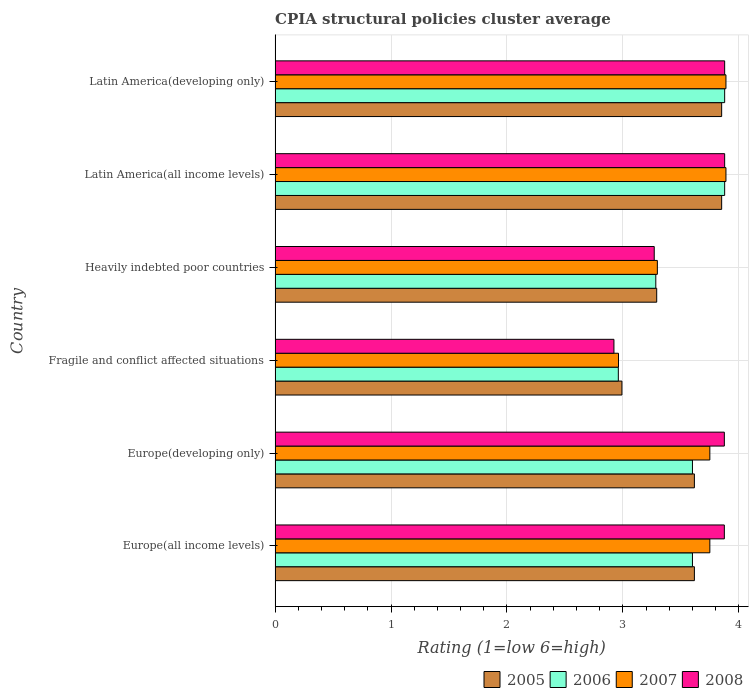How many groups of bars are there?
Ensure brevity in your answer.  6. Are the number of bars per tick equal to the number of legend labels?
Give a very brief answer. Yes. Are the number of bars on each tick of the Y-axis equal?
Ensure brevity in your answer.  Yes. How many bars are there on the 2nd tick from the top?
Your answer should be very brief. 4. How many bars are there on the 2nd tick from the bottom?
Keep it short and to the point. 4. What is the label of the 6th group of bars from the top?
Provide a short and direct response. Europe(all income levels). What is the CPIA rating in 2007 in Fragile and conflict affected situations?
Give a very brief answer. 2.96. Across all countries, what is the maximum CPIA rating in 2008?
Offer a very short reply. 3.88. Across all countries, what is the minimum CPIA rating in 2008?
Your answer should be very brief. 2.92. In which country was the CPIA rating in 2007 maximum?
Provide a succinct answer. Latin America(all income levels). In which country was the CPIA rating in 2007 minimum?
Offer a terse response. Fragile and conflict affected situations. What is the total CPIA rating in 2006 in the graph?
Offer a terse response. 21.2. What is the difference between the CPIA rating in 2005 in Europe(developing only) and that in Fragile and conflict affected situations?
Offer a terse response. 0.62. What is the difference between the CPIA rating in 2006 in Heavily indebted poor countries and the CPIA rating in 2005 in Latin America(developing only)?
Make the answer very short. -0.57. What is the average CPIA rating in 2007 per country?
Your answer should be very brief. 3.59. What is the difference between the CPIA rating in 2005 and CPIA rating in 2006 in Europe(all income levels)?
Offer a very short reply. 0.02. What is the ratio of the CPIA rating in 2007 in Europe(all income levels) to that in Heavily indebted poor countries?
Your answer should be very brief. 1.14. Is the CPIA rating in 2008 in Europe(developing only) less than that in Latin America(developing only)?
Ensure brevity in your answer.  Yes. What is the difference between the highest and the lowest CPIA rating in 2005?
Ensure brevity in your answer.  0.86. In how many countries, is the CPIA rating in 2008 greater than the average CPIA rating in 2008 taken over all countries?
Make the answer very short. 4. Is the sum of the CPIA rating in 2005 in Europe(developing only) and Fragile and conflict affected situations greater than the maximum CPIA rating in 2007 across all countries?
Your answer should be compact. Yes. What does the 1st bar from the top in Latin America(all income levels) represents?
Ensure brevity in your answer.  2008. Is it the case that in every country, the sum of the CPIA rating in 2007 and CPIA rating in 2008 is greater than the CPIA rating in 2005?
Your answer should be compact. Yes. How many bars are there?
Ensure brevity in your answer.  24. Are the values on the major ticks of X-axis written in scientific E-notation?
Give a very brief answer. No. Does the graph contain grids?
Give a very brief answer. Yes. What is the title of the graph?
Make the answer very short. CPIA structural policies cluster average. Does "1962" appear as one of the legend labels in the graph?
Your answer should be compact. No. What is the label or title of the X-axis?
Make the answer very short. Rating (1=low 6=high). What is the Rating (1=low 6=high) in 2005 in Europe(all income levels)?
Give a very brief answer. 3.62. What is the Rating (1=low 6=high) of 2007 in Europe(all income levels)?
Ensure brevity in your answer.  3.75. What is the Rating (1=low 6=high) in 2008 in Europe(all income levels)?
Your response must be concise. 3.88. What is the Rating (1=low 6=high) in 2005 in Europe(developing only)?
Offer a terse response. 3.62. What is the Rating (1=low 6=high) of 2007 in Europe(developing only)?
Provide a succinct answer. 3.75. What is the Rating (1=low 6=high) in 2008 in Europe(developing only)?
Your answer should be very brief. 3.88. What is the Rating (1=low 6=high) of 2005 in Fragile and conflict affected situations?
Keep it short and to the point. 2.99. What is the Rating (1=low 6=high) in 2006 in Fragile and conflict affected situations?
Make the answer very short. 2.96. What is the Rating (1=low 6=high) in 2007 in Fragile and conflict affected situations?
Offer a very short reply. 2.96. What is the Rating (1=low 6=high) in 2008 in Fragile and conflict affected situations?
Your response must be concise. 2.92. What is the Rating (1=low 6=high) of 2005 in Heavily indebted poor countries?
Make the answer very short. 3.29. What is the Rating (1=low 6=high) in 2006 in Heavily indebted poor countries?
Your answer should be compact. 3.28. What is the Rating (1=low 6=high) in 2007 in Heavily indebted poor countries?
Offer a terse response. 3.3. What is the Rating (1=low 6=high) in 2008 in Heavily indebted poor countries?
Offer a terse response. 3.27. What is the Rating (1=low 6=high) of 2005 in Latin America(all income levels)?
Offer a very short reply. 3.85. What is the Rating (1=low 6=high) in 2006 in Latin America(all income levels)?
Give a very brief answer. 3.88. What is the Rating (1=low 6=high) of 2007 in Latin America(all income levels)?
Provide a succinct answer. 3.89. What is the Rating (1=low 6=high) in 2008 in Latin America(all income levels)?
Your response must be concise. 3.88. What is the Rating (1=low 6=high) of 2005 in Latin America(developing only)?
Make the answer very short. 3.85. What is the Rating (1=low 6=high) of 2006 in Latin America(developing only)?
Your answer should be compact. 3.88. What is the Rating (1=low 6=high) in 2007 in Latin America(developing only)?
Your response must be concise. 3.89. What is the Rating (1=low 6=high) in 2008 in Latin America(developing only)?
Provide a succinct answer. 3.88. Across all countries, what is the maximum Rating (1=low 6=high) of 2005?
Provide a succinct answer. 3.85. Across all countries, what is the maximum Rating (1=low 6=high) of 2006?
Give a very brief answer. 3.88. Across all countries, what is the maximum Rating (1=low 6=high) in 2007?
Make the answer very short. 3.89. Across all countries, what is the maximum Rating (1=low 6=high) in 2008?
Provide a succinct answer. 3.88. Across all countries, what is the minimum Rating (1=low 6=high) of 2005?
Ensure brevity in your answer.  2.99. Across all countries, what is the minimum Rating (1=low 6=high) in 2006?
Provide a succinct answer. 2.96. Across all countries, what is the minimum Rating (1=low 6=high) of 2007?
Provide a short and direct response. 2.96. Across all countries, what is the minimum Rating (1=low 6=high) in 2008?
Your response must be concise. 2.92. What is the total Rating (1=low 6=high) of 2005 in the graph?
Offer a very short reply. 21.22. What is the total Rating (1=low 6=high) in 2006 in the graph?
Make the answer very short. 21.2. What is the total Rating (1=low 6=high) of 2007 in the graph?
Give a very brief answer. 21.54. What is the total Rating (1=low 6=high) of 2008 in the graph?
Your response must be concise. 21.7. What is the difference between the Rating (1=low 6=high) in 2007 in Europe(all income levels) and that in Europe(developing only)?
Your answer should be very brief. 0. What is the difference between the Rating (1=low 6=high) in 2008 in Europe(all income levels) and that in Europe(developing only)?
Your answer should be compact. 0. What is the difference between the Rating (1=low 6=high) in 2006 in Europe(all income levels) and that in Fragile and conflict affected situations?
Your response must be concise. 0.64. What is the difference between the Rating (1=low 6=high) of 2007 in Europe(all income levels) and that in Fragile and conflict affected situations?
Provide a short and direct response. 0.79. What is the difference between the Rating (1=low 6=high) of 2008 in Europe(all income levels) and that in Fragile and conflict affected situations?
Your answer should be compact. 0.95. What is the difference between the Rating (1=low 6=high) in 2005 in Europe(all income levels) and that in Heavily indebted poor countries?
Keep it short and to the point. 0.33. What is the difference between the Rating (1=low 6=high) of 2006 in Europe(all income levels) and that in Heavily indebted poor countries?
Make the answer very short. 0.32. What is the difference between the Rating (1=low 6=high) of 2007 in Europe(all income levels) and that in Heavily indebted poor countries?
Give a very brief answer. 0.45. What is the difference between the Rating (1=low 6=high) in 2008 in Europe(all income levels) and that in Heavily indebted poor countries?
Your response must be concise. 0.6. What is the difference between the Rating (1=low 6=high) of 2005 in Europe(all income levels) and that in Latin America(all income levels)?
Make the answer very short. -0.24. What is the difference between the Rating (1=low 6=high) in 2006 in Europe(all income levels) and that in Latin America(all income levels)?
Ensure brevity in your answer.  -0.28. What is the difference between the Rating (1=low 6=high) of 2007 in Europe(all income levels) and that in Latin America(all income levels)?
Ensure brevity in your answer.  -0.14. What is the difference between the Rating (1=low 6=high) of 2008 in Europe(all income levels) and that in Latin America(all income levels)?
Your response must be concise. -0. What is the difference between the Rating (1=low 6=high) of 2005 in Europe(all income levels) and that in Latin America(developing only)?
Offer a very short reply. -0.24. What is the difference between the Rating (1=low 6=high) of 2006 in Europe(all income levels) and that in Latin America(developing only)?
Keep it short and to the point. -0.28. What is the difference between the Rating (1=low 6=high) in 2007 in Europe(all income levels) and that in Latin America(developing only)?
Provide a short and direct response. -0.14. What is the difference between the Rating (1=low 6=high) in 2008 in Europe(all income levels) and that in Latin America(developing only)?
Make the answer very short. -0. What is the difference between the Rating (1=low 6=high) of 2005 in Europe(developing only) and that in Fragile and conflict affected situations?
Your answer should be compact. 0.62. What is the difference between the Rating (1=low 6=high) in 2006 in Europe(developing only) and that in Fragile and conflict affected situations?
Your answer should be compact. 0.64. What is the difference between the Rating (1=low 6=high) of 2007 in Europe(developing only) and that in Fragile and conflict affected situations?
Keep it short and to the point. 0.79. What is the difference between the Rating (1=low 6=high) in 2008 in Europe(developing only) and that in Fragile and conflict affected situations?
Keep it short and to the point. 0.95. What is the difference between the Rating (1=low 6=high) in 2005 in Europe(developing only) and that in Heavily indebted poor countries?
Your answer should be compact. 0.33. What is the difference between the Rating (1=low 6=high) in 2006 in Europe(developing only) and that in Heavily indebted poor countries?
Your response must be concise. 0.32. What is the difference between the Rating (1=low 6=high) of 2007 in Europe(developing only) and that in Heavily indebted poor countries?
Your answer should be very brief. 0.45. What is the difference between the Rating (1=low 6=high) of 2008 in Europe(developing only) and that in Heavily indebted poor countries?
Make the answer very short. 0.6. What is the difference between the Rating (1=low 6=high) of 2005 in Europe(developing only) and that in Latin America(all income levels)?
Ensure brevity in your answer.  -0.24. What is the difference between the Rating (1=low 6=high) in 2006 in Europe(developing only) and that in Latin America(all income levels)?
Your answer should be compact. -0.28. What is the difference between the Rating (1=low 6=high) of 2007 in Europe(developing only) and that in Latin America(all income levels)?
Your answer should be compact. -0.14. What is the difference between the Rating (1=low 6=high) in 2008 in Europe(developing only) and that in Latin America(all income levels)?
Your answer should be compact. -0. What is the difference between the Rating (1=low 6=high) of 2005 in Europe(developing only) and that in Latin America(developing only)?
Provide a succinct answer. -0.24. What is the difference between the Rating (1=low 6=high) in 2006 in Europe(developing only) and that in Latin America(developing only)?
Offer a terse response. -0.28. What is the difference between the Rating (1=low 6=high) in 2007 in Europe(developing only) and that in Latin America(developing only)?
Offer a terse response. -0.14. What is the difference between the Rating (1=low 6=high) in 2008 in Europe(developing only) and that in Latin America(developing only)?
Keep it short and to the point. -0. What is the difference between the Rating (1=low 6=high) in 2005 in Fragile and conflict affected situations and that in Heavily indebted poor countries?
Keep it short and to the point. -0.3. What is the difference between the Rating (1=low 6=high) in 2006 in Fragile and conflict affected situations and that in Heavily indebted poor countries?
Provide a short and direct response. -0.32. What is the difference between the Rating (1=low 6=high) of 2007 in Fragile and conflict affected situations and that in Heavily indebted poor countries?
Give a very brief answer. -0.34. What is the difference between the Rating (1=low 6=high) in 2008 in Fragile and conflict affected situations and that in Heavily indebted poor countries?
Ensure brevity in your answer.  -0.35. What is the difference between the Rating (1=low 6=high) in 2005 in Fragile and conflict affected situations and that in Latin America(all income levels)?
Your answer should be compact. -0.86. What is the difference between the Rating (1=low 6=high) of 2006 in Fragile and conflict affected situations and that in Latin America(all income levels)?
Provide a short and direct response. -0.92. What is the difference between the Rating (1=low 6=high) of 2007 in Fragile and conflict affected situations and that in Latin America(all income levels)?
Keep it short and to the point. -0.93. What is the difference between the Rating (1=low 6=high) of 2008 in Fragile and conflict affected situations and that in Latin America(all income levels)?
Provide a short and direct response. -0.96. What is the difference between the Rating (1=low 6=high) in 2005 in Fragile and conflict affected situations and that in Latin America(developing only)?
Give a very brief answer. -0.86. What is the difference between the Rating (1=low 6=high) of 2006 in Fragile and conflict affected situations and that in Latin America(developing only)?
Provide a succinct answer. -0.92. What is the difference between the Rating (1=low 6=high) of 2007 in Fragile and conflict affected situations and that in Latin America(developing only)?
Offer a very short reply. -0.93. What is the difference between the Rating (1=low 6=high) of 2008 in Fragile and conflict affected situations and that in Latin America(developing only)?
Provide a succinct answer. -0.96. What is the difference between the Rating (1=low 6=high) in 2005 in Heavily indebted poor countries and that in Latin America(all income levels)?
Ensure brevity in your answer.  -0.56. What is the difference between the Rating (1=low 6=high) in 2006 in Heavily indebted poor countries and that in Latin America(all income levels)?
Provide a succinct answer. -0.59. What is the difference between the Rating (1=low 6=high) in 2007 in Heavily indebted poor countries and that in Latin America(all income levels)?
Offer a terse response. -0.59. What is the difference between the Rating (1=low 6=high) in 2008 in Heavily indebted poor countries and that in Latin America(all income levels)?
Your answer should be very brief. -0.61. What is the difference between the Rating (1=low 6=high) of 2005 in Heavily indebted poor countries and that in Latin America(developing only)?
Your answer should be very brief. -0.56. What is the difference between the Rating (1=low 6=high) of 2006 in Heavily indebted poor countries and that in Latin America(developing only)?
Your response must be concise. -0.59. What is the difference between the Rating (1=low 6=high) in 2007 in Heavily indebted poor countries and that in Latin America(developing only)?
Make the answer very short. -0.59. What is the difference between the Rating (1=low 6=high) of 2008 in Heavily indebted poor countries and that in Latin America(developing only)?
Provide a short and direct response. -0.61. What is the difference between the Rating (1=low 6=high) in 2007 in Latin America(all income levels) and that in Latin America(developing only)?
Your response must be concise. 0. What is the difference between the Rating (1=low 6=high) in 2008 in Latin America(all income levels) and that in Latin America(developing only)?
Provide a succinct answer. 0. What is the difference between the Rating (1=low 6=high) in 2005 in Europe(all income levels) and the Rating (1=low 6=high) in 2006 in Europe(developing only)?
Your answer should be very brief. 0.02. What is the difference between the Rating (1=low 6=high) of 2005 in Europe(all income levels) and the Rating (1=low 6=high) of 2007 in Europe(developing only)?
Your response must be concise. -0.13. What is the difference between the Rating (1=low 6=high) in 2005 in Europe(all income levels) and the Rating (1=low 6=high) in 2008 in Europe(developing only)?
Keep it short and to the point. -0.26. What is the difference between the Rating (1=low 6=high) of 2006 in Europe(all income levels) and the Rating (1=low 6=high) of 2008 in Europe(developing only)?
Give a very brief answer. -0.28. What is the difference between the Rating (1=low 6=high) in 2007 in Europe(all income levels) and the Rating (1=low 6=high) in 2008 in Europe(developing only)?
Offer a terse response. -0.12. What is the difference between the Rating (1=low 6=high) in 2005 in Europe(all income levels) and the Rating (1=low 6=high) in 2006 in Fragile and conflict affected situations?
Keep it short and to the point. 0.66. What is the difference between the Rating (1=low 6=high) of 2005 in Europe(all income levels) and the Rating (1=low 6=high) of 2007 in Fragile and conflict affected situations?
Give a very brief answer. 0.65. What is the difference between the Rating (1=low 6=high) of 2005 in Europe(all income levels) and the Rating (1=low 6=high) of 2008 in Fragile and conflict affected situations?
Make the answer very short. 0.69. What is the difference between the Rating (1=low 6=high) in 2006 in Europe(all income levels) and the Rating (1=low 6=high) in 2007 in Fragile and conflict affected situations?
Give a very brief answer. 0.64. What is the difference between the Rating (1=low 6=high) in 2006 in Europe(all income levels) and the Rating (1=low 6=high) in 2008 in Fragile and conflict affected situations?
Offer a very short reply. 0.68. What is the difference between the Rating (1=low 6=high) in 2007 in Europe(all income levels) and the Rating (1=low 6=high) in 2008 in Fragile and conflict affected situations?
Make the answer very short. 0.83. What is the difference between the Rating (1=low 6=high) in 2005 in Europe(all income levels) and the Rating (1=low 6=high) in 2006 in Heavily indebted poor countries?
Your answer should be compact. 0.33. What is the difference between the Rating (1=low 6=high) of 2005 in Europe(all income levels) and the Rating (1=low 6=high) of 2007 in Heavily indebted poor countries?
Keep it short and to the point. 0.32. What is the difference between the Rating (1=low 6=high) of 2005 in Europe(all income levels) and the Rating (1=low 6=high) of 2008 in Heavily indebted poor countries?
Your response must be concise. 0.35. What is the difference between the Rating (1=low 6=high) in 2006 in Europe(all income levels) and the Rating (1=low 6=high) in 2007 in Heavily indebted poor countries?
Ensure brevity in your answer.  0.3. What is the difference between the Rating (1=low 6=high) in 2006 in Europe(all income levels) and the Rating (1=low 6=high) in 2008 in Heavily indebted poor countries?
Ensure brevity in your answer.  0.33. What is the difference between the Rating (1=low 6=high) in 2007 in Europe(all income levels) and the Rating (1=low 6=high) in 2008 in Heavily indebted poor countries?
Ensure brevity in your answer.  0.48. What is the difference between the Rating (1=low 6=high) of 2005 in Europe(all income levels) and the Rating (1=low 6=high) of 2006 in Latin America(all income levels)?
Your response must be concise. -0.26. What is the difference between the Rating (1=low 6=high) in 2005 in Europe(all income levels) and the Rating (1=low 6=high) in 2007 in Latin America(all income levels)?
Offer a terse response. -0.27. What is the difference between the Rating (1=low 6=high) in 2005 in Europe(all income levels) and the Rating (1=low 6=high) in 2008 in Latin America(all income levels)?
Offer a terse response. -0.26. What is the difference between the Rating (1=low 6=high) of 2006 in Europe(all income levels) and the Rating (1=low 6=high) of 2007 in Latin America(all income levels)?
Make the answer very short. -0.29. What is the difference between the Rating (1=low 6=high) in 2006 in Europe(all income levels) and the Rating (1=low 6=high) in 2008 in Latin America(all income levels)?
Your answer should be compact. -0.28. What is the difference between the Rating (1=low 6=high) in 2007 in Europe(all income levels) and the Rating (1=low 6=high) in 2008 in Latin America(all income levels)?
Offer a very short reply. -0.13. What is the difference between the Rating (1=low 6=high) of 2005 in Europe(all income levels) and the Rating (1=low 6=high) of 2006 in Latin America(developing only)?
Give a very brief answer. -0.26. What is the difference between the Rating (1=low 6=high) of 2005 in Europe(all income levels) and the Rating (1=low 6=high) of 2007 in Latin America(developing only)?
Offer a terse response. -0.27. What is the difference between the Rating (1=low 6=high) in 2005 in Europe(all income levels) and the Rating (1=low 6=high) in 2008 in Latin America(developing only)?
Make the answer very short. -0.26. What is the difference between the Rating (1=low 6=high) of 2006 in Europe(all income levels) and the Rating (1=low 6=high) of 2007 in Latin America(developing only)?
Your response must be concise. -0.29. What is the difference between the Rating (1=low 6=high) in 2006 in Europe(all income levels) and the Rating (1=low 6=high) in 2008 in Latin America(developing only)?
Provide a succinct answer. -0.28. What is the difference between the Rating (1=low 6=high) in 2007 in Europe(all income levels) and the Rating (1=low 6=high) in 2008 in Latin America(developing only)?
Give a very brief answer. -0.13. What is the difference between the Rating (1=low 6=high) in 2005 in Europe(developing only) and the Rating (1=low 6=high) in 2006 in Fragile and conflict affected situations?
Ensure brevity in your answer.  0.66. What is the difference between the Rating (1=low 6=high) in 2005 in Europe(developing only) and the Rating (1=low 6=high) in 2007 in Fragile and conflict affected situations?
Offer a terse response. 0.65. What is the difference between the Rating (1=low 6=high) of 2005 in Europe(developing only) and the Rating (1=low 6=high) of 2008 in Fragile and conflict affected situations?
Offer a terse response. 0.69. What is the difference between the Rating (1=low 6=high) in 2006 in Europe(developing only) and the Rating (1=low 6=high) in 2007 in Fragile and conflict affected situations?
Make the answer very short. 0.64. What is the difference between the Rating (1=low 6=high) in 2006 in Europe(developing only) and the Rating (1=low 6=high) in 2008 in Fragile and conflict affected situations?
Provide a short and direct response. 0.68. What is the difference between the Rating (1=low 6=high) in 2007 in Europe(developing only) and the Rating (1=low 6=high) in 2008 in Fragile and conflict affected situations?
Make the answer very short. 0.83. What is the difference between the Rating (1=low 6=high) of 2005 in Europe(developing only) and the Rating (1=low 6=high) of 2006 in Heavily indebted poor countries?
Provide a succinct answer. 0.33. What is the difference between the Rating (1=low 6=high) in 2005 in Europe(developing only) and the Rating (1=low 6=high) in 2007 in Heavily indebted poor countries?
Provide a short and direct response. 0.32. What is the difference between the Rating (1=low 6=high) in 2005 in Europe(developing only) and the Rating (1=low 6=high) in 2008 in Heavily indebted poor countries?
Your answer should be very brief. 0.35. What is the difference between the Rating (1=low 6=high) of 2006 in Europe(developing only) and the Rating (1=low 6=high) of 2007 in Heavily indebted poor countries?
Your answer should be very brief. 0.3. What is the difference between the Rating (1=low 6=high) of 2006 in Europe(developing only) and the Rating (1=low 6=high) of 2008 in Heavily indebted poor countries?
Keep it short and to the point. 0.33. What is the difference between the Rating (1=low 6=high) in 2007 in Europe(developing only) and the Rating (1=low 6=high) in 2008 in Heavily indebted poor countries?
Give a very brief answer. 0.48. What is the difference between the Rating (1=low 6=high) in 2005 in Europe(developing only) and the Rating (1=low 6=high) in 2006 in Latin America(all income levels)?
Provide a short and direct response. -0.26. What is the difference between the Rating (1=low 6=high) in 2005 in Europe(developing only) and the Rating (1=low 6=high) in 2007 in Latin America(all income levels)?
Provide a short and direct response. -0.27. What is the difference between the Rating (1=low 6=high) in 2005 in Europe(developing only) and the Rating (1=low 6=high) in 2008 in Latin America(all income levels)?
Ensure brevity in your answer.  -0.26. What is the difference between the Rating (1=low 6=high) in 2006 in Europe(developing only) and the Rating (1=low 6=high) in 2007 in Latin America(all income levels)?
Offer a very short reply. -0.29. What is the difference between the Rating (1=low 6=high) of 2006 in Europe(developing only) and the Rating (1=low 6=high) of 2008 in Latin America(all income levels)?
Your answer should be very brief. -0.28. What is the difference between the Rating (1=low 6=high) in 2007 in Europe(developing only) and the Rating (1=low 6=high) in 2008 in Latin America(all income levels)?
Offer a terse response. -0.13. What is the difference between the Rating (1=low 6=high) of 2005 in Europe(developing only) and the Rating (1=low 6=high) of 2006 in Latin America(developing only)?
Provide a succinct answer. -0.26. What is the difference between the Rating (1=low 6=high) of 2005 in Europe(developing only) and the Rating (1=low 6=high) of 2007 in Latin America(developing only)?
Your response must be concise. -0.27. What is the difference between the Rating (1=low 6=high) of 2005 in Europe(developing only) and the Rating (1=low 6=high) of 2008 in Latin America(developing only)?
Your answer should be very brief. -0.26. What is the difference between the Rating (1=low 6=high) in 2006 in Europe(developing only) and the Rating (1=low 6=high) in 2007 in Latin America(developing only)?
Your answer should be very brief. -0.29. What is the difference between the Rating (1=low 6=high) in 2006 in Europe(developing only) and the Rating (1=low 6=high) in 2008 in Latin America(developing only)?
Your response must be concise. -0.28. What is the difference between the Rating (1=low 6=high) in 2007 in Europe(developing only) and the Rating (1=low 6=high) in 2008 in Latin America(developing only)?
Your answer should be compact. -0.13. What is the difference between the Rating (1=low 6=high) in 2005 in Fragile and conflict affected situations and the Rating (1=low 6=high) in 2006 in Heavily indebted poor countries?
Make the answer very short. -0.29. What is the difference between the Rating (1=low 6=high) in 2005 in Fragile and conflict affected situations and the Rating (1=low 6=high) in 2007 in Heavily indebted poor countries?
Offer a terse response. -0.31. What is the difference between the Rating (1=low 6=high) in 2005 in Fragile and conflict affected situations and the Rating (1=low 6=high) in 2008 in Heavily indebted poor countries?
Offer a very short reply. -0.28. What is the difference between the Rating (1=low 6=high) of 2006 in Fragile and conflict affected situations and the Rating (1=low 6=high) of 2007 in Heavily indebted poor countries?
Your answer should be very brief. -0.34. What is the difference between the Rating (1=low 6=high) of 2006 in Fragile and conflict affected situations and the Rating (1=low 6=high) of 2008 in Heavily indebted poor countries?
Make the answer very short. -0.31. What is the difference between the Rating (1=low 6=high) in 2007 in Fragile and conflict affected situations and the Rating (1=low 6=high) in 2008 in Heavily indebted poor countries?
Offer a very short reply. -0.31. What is the difference between the Rating (1=low 6=high) of 2005 in Fragile and conflict affected situations and the Rating (1=low 6=high) of 2006 in Latin America(all income levels)?
Offer a terse response. -0.89. What is the difference between the Rating (1=low 6=high) in 2005 in Fragile and conflict affected situations and the Rating (1=low 6=high) in 2007 in Latin America(all income levels)?
Give a very brief answer. -0.9. What is the difference between the Rating (1=low 6=high) in 2005 in Fragile and conflict affected situations and the Rating (1=low 6=high) in 2008 in Latin America(all income levels)?
Offer a terse response. -0.89. What is the difference between the Rating (1=low 6=high) of 2006 in Fragile and conflict affected situations and the Rating (1=low 6=high) of 2007 in Latin America(all income levels)?
Offer a terse response. -0.93. What is the difference between the Rating (1=low 6=high) of 2006 in Fragile and conflict affected situations and the Rating (1=low 6=high) of 2008 in Latin America(all income levels)?
Your answer should be very brief. -0.92. What is the difference between the Rating (1=low 6=high) of 2007 in Fragile and conflict affected situations and the Rating (1=low 6=high) of 2008 in Latin America(all income levels)?
Your answer should be very brief. -0.92. What is the difference between the Rating (1=low 6=high) of 2005 in Fragile and conflict affected situations and the Rating (1=low 6=high) of 2006 in Latin America(developing only)?
Your answer should be compact. -0.89. What is the difference between the Rating (1=low 6=high) of 2005 in Fragile and conflict affected situations and the Rating (1=low 6=high) of 2007 in Latin America(developing only)?
Offer a terse response. -0.9. What is the difference between the Rating (1=low 6=high) in 2005 in Fragile and conflict affected situations and the Rating (1=low 6=high) in 2008 in Latin America(developing only)?
Ensure brevity in your answer.  -0.89. What is the difference between the Rating (1=low 6=high) in 2006 in Fragile and conflict affected situations and the Rating (1=low 6=high) in 2007 in Latin America(developing only)?
Provide a short and direct response. -0.93. What is the difference between the Rating (1=low 6=high) of 2006 in Fragile and conflict affected situations and the Rating (1=low 6=high) of 2008 in Latin America(developing only)?
Ensure brevity in your answer.  -0.92. What is the difference between the Rating (1=low 6=high) of 2007 in Fragile and conflict affected situations and the Rating (1=low 6=high) of 2008 in Latin America(developing only)?
Make the answer very short. -0.92. What is the difference between the Rating (1=low 6=high) in 2005 in Heavily indebted poor countries and the Rating (1=low 6=high) in 2006 in Latin America(all income levels)?
Provide a succinct answer. -0.59. What is the difference between the Rating (1=low 6=high) of 2005 in Heavily indebted poor countries and the Rating (1=low 6=high) of 2007 in Latin America(all income levels)?
Offer a terse response. -0.6. What is the difference between the Rating (1=low 6=high) in 2005 in Heavily indebted poor countries and the Rating (1=low 6=high) in 2008 in Latin America(all income levels)?
Offer a terse response. -0.59. What is the difference between the Rating (1=low 6=high) of 2006 in Heavily indebted poor countries and the Rating (1=low 6=high) of 2007 in Latin America(all income levels)?
Provide a short and direct response. -0.61. What is the difference between the Rating (1=low 6=high) in 2006 in Heavily indebted poor countries and the Rating (1=low 6=high) in 2008 in Latin America(all income levels)?
Give a very brief answer. -0.59. What is the difference between the Rating (1=low 6=high) of 2007 in Heavily indebted poor countries and the Rating (1=low 6=high) of 2008 in Latin America(all income levels)?
Make the answer very short. -0.58. What is the difference between the Rating (1=low 6=high) of 2005 in Heavily indebted poor countries and the Rating (1=low 6=high) of 2006 in Latin America(developing only)?
Offer a very short reply. -0.59. What is the difference between the Rating (1=low 6=high) of 2005 in Heavily indebted poor countries and the Rating (1=low 6=high) of 2007 in Latin America(developing only)?
Your response must be concise. -0.6. What is the difference between the Rating (1=low 6=high) of 2005 in Heavily indebted poor countries and the Rating (1=low 6=high) of 2008 in Latin America(developing only)?
Provide a short and direct response. -0.59. What is the difference between the Rating (1=low 6=high) in 2006 in Heavily indebted poor countries and the Rating (1=low 6=high) in 2007 in Latin America(developing only)?
Offer a terse response. -0.61. What is the difference between the Rating (1=low 6=high) in 2006 in Heavily indebted poor countries and the Rating (1=low 6=high) in 2008 in Latin America(developing only)?
Your answer should be compact. -0.59. What is the difference between the Rating (1=low 6=high) of 2007 in Heavily indebted poor countries and the Rating (1=low 6=high) of 2008 in Latin America(developing only)?
Give a very brief answer. -0.58. What is the difference between the Rating (1=low 6=high) of 2005 in Latin America(all income levels) and the Rating (1=low 6=high) of 2006 in Latin America(developing only)?
Your answer should be very brief. -0.03. What is the difference between the Rating (1=low 6=high) of 2005 in Latin America(all income levels) and the Rating (1=low 6=high) of 2007 in Latin America(developing only)?
Provide a succinct answer. -0.04. What is the difference between the Rating (1=low 6=high) in 2005 in Latin America(all income levels) and the Rating (1=low 6=high) in 2008 in Latin America(developing only)?
Offer a terse response. -0.03. What is the difference between the Rating (1=low 6=high) of 2006 in Latin America(all income levels) and the Rating (1=low 6=high) of 2007 in Latin America(developing only)?
Make the answer very short. -0.01. What is the difference between the Rating (1=low 6=high) of 2007 in Latin America(all income levels) and the Rating (1=low 6=high) of 2008 in Latin America(developing only)?
Provide a succinct answer. 0.01. What is the average Rating (1=low 6=high) in 2005 per country?
Your answer should be compact. 3.54. What is the average Rating (1=low 6=high) of 2006 per country?
Provide a short and direct response. 3.53. What is the average Rating (1=low 6=high) in 2007 per country?
Your response must be concise. 3.59. What is the average Rating (1=low 6=high) of 2008 per country?
Provide a short and direct response. 3.62. What is the difference between the Rating (1=low 6=high) in 2005 and Rating (1=low 6=high) in 2006 in Europe(all income levels)?
Provide a short and direct response. 0.02. What is the difference between the Rating (1=low 6=high) of 2005 and Rating (1=low 6=high) of 2007 in Europe(all income levels)?
Provide a short and direct response. -0.13. What is the difference between the Rating (1=low 6=high) in 2005 and Rating (1=low 6=high) in 2008 in Europe(all income levels)?
Give a very brief answer. -0.26. What is the difference between the Rating (1=low 6=high) in 2006 and Rating (1=low 6=high) in 2007 in Europe(all income levels)?
Give a very brief answer. -0.15. What is the difference between the Rating (1=low 6=high) in 2006 and Rating (1=low 6=high) in 2008 in Europe(all income levels)?
Give a very brief answer. -0.28. What is the difference between the Rating (1=low 6=high) in 2007 and Rating (1=low 6=high) in 2008 in Europe(all income levels)?
Your answer should be compact. -0.12. What is the difference between the Rating (1=low 6=high) in 2005 and Rating (1=low 6=high) in 2006 in Europe(developing only)?
Offer a terse response. 0.02. What is the difference between the Rating (1=low 6=high) of 2005 and Rating (1=low 6=high) of 2007 in Europe(developing only)?
Ensure brevity in your answer.  -0.13. What is the difference between the Rating (1=low 6=high) in 2005 and Rating (1=low 6=high) in 2008 in Europe(developing only)?
Keep it short and to the point. -0.26. What is the difference between the Rating (1=low 6=high) in 2006 and Rating (1=low 6=high) in 2007 in Europe(developing only)?
Provide a short and direct response. -0.15. What is the difference between the Rating (1=low 6=high) in 2006 and Rating (1=low 6=high) in 2008 in Europe(developing only)?
Give a very brief answer. -0.28. What is the difference between the Rating (1=low 6=high) of 2007 and Rating (1=low 6=high) of 2008 in Europe(developing only)?
Make the answer very short. -0.12. What is the difference between the Rating (1=low 6=high) of 2005 and Rating (1=low 6=high) of 2006 in Fragile and conflict affected situations?
Make the answer very short. 0.03. What is the difference between the Rating (1=low 6=high) of 2005 and Rating (1=low 6=high) of 2007 in Fragile and conflict affected situations?
Make the answer very short. 0.03. What is the difference between the Rating (1=low 6=high) in 2005 and Rating (1=low 6=high) in 2008 in Fragile and conflict affected situations?
Offer a terse response. 0.07. What is the difference between the Rating (1=low 6=high) in 2006 and Rating (1=low 6=high) in 2007 in Fragile and conflict affected situations?
Provide a succinct answer. -0. What is the difference between the Rating (1=low 6=high) of 2006 and Rating (1=low 6=high) of 2008 in Fragile and conflict affected situations?
Ensure brevity in your answer.  0.04. What is the difference between the Rating (1=low 6=high) in 2007 and Rating (1=low 6=high) in 2008 in Fragile and conflict affected situations?
Your response must be concise. 0.04. What is the difference between the Rating (1=low 6=high) of 2005 and Rating (1=low 6=high) of 2006 in Heavily indebted poor countries?
Offer a terse response. 0.01. What is the difference between the Rating (1=low 6=high) in 2005 and Rating (1=low 6=high) in 2007 in Heavily indebted poor countries?
Keep it short and to the point. -0.01. What is the difference between the Rating (1=low 6=high) of 2005 and Rating (1=low 6=high) of 2008 in Heavily indebted poor countries?
Give a very brief answer. 0.02. What is the difference between the Rating (1=low 6=high) in 2006 and Rating (1=low 6=high) in 2007 in Heavily indebted poor countries?
Provide a succinct answer. -0.01. What is the difference between the Rating (1=low 6=high) of 2006 and Rating (1=low 6=high) of 2008 in Heavily indebted poor countries?
Make the answer very short. 0.01. What is the difference between the Rating (1=low 6=high) in 2007 and Rating (1=low 6=high) in 2008 in Heavily indebted poor countries?
Provide a short and direct response. 0.03. What is the difference between the Rating (1=low 6=high) in 2005 and Rating (1=low 6=high) in 2006 in Latin America(all income levels)?
Your response must be concise. -0.03. What is the difference between the Rating (1=low 6=high) of 2005 and Rating (1=low 6=high) of 2007 in Latin America(all income levels)?
Keep it short and to the point. -0.04. What is the difference between the Rating (1=low 6=high) in 2005 and Rating (1=low 6=high) in 2008 in Latin America(all income levels)?
Offer a terse response. -0.03. What is the difference between the Rating (1=low 6=high) of 2006 and Rating (1=low 6=high) of 2007 in Latin America(all income levels)?
Provide a succinct answer. -0.01. What is the difference between the Rating (1=low 6=high) in 2007 and Rating (1=low 6=high) in 2008 in Latin America(all income levels)?
Provide a succinct answer. 0.01. What is the difference between the Rating (1=low 6=high) of 2005 and Rating (1=low 6=high) of 2006 in Latin America(developing only)?
Give a very brief answer. -0.03. What is the difference between the Rating (1=low 6=high) of 2005 and Rating (1=low 6=high) of 2007 in Latin America(developing only)?
Make the answer very short. -0.04. What is the difference between the Rating (1=low 6=high) of 2005 and Rating (1=low 6=high) of 2008 in Latin America(developing only)?
Your answer should be very brief. -0.03. What is the difference between the Rating (1=low 6=high) in 2006 and Rating (1=low 6=high) in 2007 in Latin America(developing only)?
Keep it short and to the point. -0.01. What is the difference between the Rating (1=low 6=high) in 2006 and Rating (1=low 6=high) in 2008 in Latin America(developing only)?
Offer a very short reply. 0. What is the difference between the Rating (1=low 6=high) in 2007 and Rating (1=low 6=high) in 2008 in Latin America(developing only)?
Provide a succinct answer. 0.01. What is the ratio of the Rating (1=low 6=high) in 2005 in Europe(all income levels) to that in Europe(developing only)?
Offer a terse response. 1. What is the ratio of the Rating (1=low 6=high) of 2007 in Europe(all income levels) to that in Europe(developing only)?
Provide a short and direct response. 1. What is the ratio of the Rating (1=low 6=high) of 2008 in Europe(all income levels) to that in Europe(developing only)?
Offer a terse response. 1. What is the ratio of the Rating (1=low 6=high) of 2005 in Europe(all income levels) to that in Fragile and conflict affected situations?
Provide a succinct answer. 1.21. What is the ratio of the Rating (1=low 6=high) of 2006 in Europe(all income levels) to that in Fragile and conflict affected situations?
Ensure brevity in your answer.  1.22. What is the ratio of the Rating (1=low 6=high) of 2007 in Europe(all income levels) to that in Fragile and conflict affected situations?
Offer a terse response. 1.27. What is the ratio of the Rating (1=low 6=high) in 2008 in Europe(all income levels) to that in Fragile and conflict affected situations?
Your answer should be compact. 1.33. What is the ratio of the Rating (1=low 6=high) of 2005 in Europe(all income levels) to that in Heavily indebted poor countries?
Make the answer very short. 1.1. What is the ratio of the Rating (1=low 6=high) in 2006 in Europe(all income levels) to that in Heavily indebted poor countries?
Give a very brief answer. 1.1. What is the ratio of the Rating (1=low 6=high) of 2007 in Europe(all income levels) to that in Heavily indebted poor countries?
Keep it short and to the point. 1.14. What is the ratio of the Rating (1=low 6=high) of 2008 in Europe(all income levels) to that in Heavily indebted poor countries?
Make the answer very short. 1.18. What is the ratio of the Rating (1=low 6=high) of 2005 in Europe(all income levels) to that in Latin America(all income levels)?
Provide a short and direct response. 0.94. What is the ratio of the Rating (1=low 6=high) in 2006 in Europe(all income levels) to that in Latin America(all income levels)?
Make the answer very short. 0.93. What is the ratio of the Rating (1=low 6=high) of 2007 in Europe(all income levels) to that in Latin America(all income levels)?
Give a very brief answer. 0.96. What is the ratio of the Rating (1=low 6=high) in 2005 in Europe(all income levels) to that in Latin America(developing only)?
Give a very brief answer. 0.94. What is the ratio of the Rating (1=low 6=high) in 2006 in Europe(all income levels) to that in Latin America(developing only)?
Provide a short and direct response. 0.93. What is the ratio of the Rating (1=low 6=high) in 2008 in Europe(all income levels) to that in Latin America(developing only)?
Make the answer very short. 1. What is the ratio of the Rating (1=low 6=high) of 2005 in Europe(developing only) to that in Fragile and conflict affected situations?
Provide a short and direct response. 1.21. What is the ratio of the Rating (1=low 6=high) in 2006 in Europe(developing only) to that in Fragile and conflict affected situations?
Your answer should be very brief. 1.22. What is the ratio of the Rating (1=low 6=high) of 2007 in Europe(developing only) to that in Fragile and conflict affected situations?
Ensure brevity in your answer.  1.27. What is the ratio of the Rating (1=low 6=high) in 2008 in Europe(developing only) to that in Fragile and conflict affected situations?
Offer a terse response. 1.33. What is the ratio of the Rating (1=low 6=high) of 2005 in Europe(developing only) to that in Heavily indebted poor countries?
Ensure brevity in your answer.  1.1. What is the ratio of the Rating (1=low 6=high) in 2006 in Europe(developing only) to that in Heavily indebted poor countries?
Keep it short and to the point. 1.1. What is the ratio of the Rating (1=low 6=high) of 2007 in Europe(developing only) to that in Heavily indebted poor countries?
Offer a very short reply. 1.14. What is the ratio of the Rating (1=low 6=high) in 2008 in Europe(developing only) to that in Heavily indebted poor countries?
Ensure brevity in your answer.  1.18. What is the ratio of the Rating (1=low 6=high) of 2005 in Europe(developing only) to that in Latin America(all income levels)?
Offer a very short reply. 0.94. What is the ratio of the Rating (1=low 6=high) in 2006 in Europe(developing only) to that in Latin America(all income levels)?
Make the answer very short. 0.93. What is the ratio of the Rating (1=low 6=high) in 2005 in Europe(developing only) to that in Latin America(developing only)?
Offer a terse response. 0.94. What is the ratio of the Rating (1=low 6=high) of 2006 in Europe(developing only) to that in Latin America(developing only)?
Your answer should be compact. 0.93. What is the ratio of the Rating (1=low 6=high) in 2007 in Europe(developing only) to that in Latin America(developing only)?
Your answer should be very brief. 0.96. What is the ratio of the Rating (1=low 6=high) of 2005 in Fragile and conflict affected situations to that in Heavily indebted poor countries?
Your response must be concise. 0.91. What is the ratio of the Rating (1=low 6=high) in 2006 in Fragile and conflict affected situations to that in Heavily indebted poor countries?
Give a very brief answer. 0.9. What is the ratio of the Rating (1=low 6=high) of 2007 in Fragile and conflict affected situations to that in Heavily indebted poor countries?
Offer a terse response. 0.9. What is the ratio of the Rating (1=low 6=high) in 2008 in Fragile and conflict affected situations to that in Heavily indebted poor countries?
Give a very brief answer. 0.89. What is the ratio of the Rating (1=low 6=high) in 2005 in Fragile and conflict affected situations to that in Latin America(all income levels)?
Your answer should be very brief. 0.78. What is the ratio of the Rating (1=low 6=high) in 2006 in Fragile and conflict affected situations to that in Latin America(all income levels)?
Give a very brief answer. 0.76. What is the ratio of the Rating (1=low 6=high) in 2007 in Fragile and conflict affected situations to that in Latin America(all income levels)?
Your answer should be compact. 0.76. What is the ratio of the Rating (1=low 6=high) in 2008 in Fragile and conflict affected situations to that in Latin America(all income levels)?
Provide a succinct answer. 0.75. What is the ratio of the Rating (1=low 6=high) in 2005 in Fragile and conflict affected situations to that in Latin America(developing only)?
Keep it short and to the point. 0.78. What is the ratio of the Rating (1=low 6=high) of 2006 in Fragile and conflict affected situations to that in Latin America(developing only)?
Keep it short and to the point. 0.76. What is the ratio of the Rating (1=low 6=high) of 2007 in Fragile and conflict affected situations to that in Latin America(developing only)?
Your answer should be compact. 0.76. What is the ratio of the Rating (1=low 6=high) of 2008 in Fragile and conflict affected situations to that in Latin America(developing only)?
Give a very brief answer. 0.75. What is the ratio of the Rating (1=low 6=high) of 2005 in Heavily indebted poor countries to that in Latin America(all income levels)?
Your answer should be compact. 0.85. What is the ratio of the Rating (1=low 6=high) of 2006 in Heavily indebted poor countries to that in Latin America(all income levels)?
Offer a terse response. 0.85. What is the ratio of the Rating (1=low 6=high) in 2007 in Heavily indebted poor countries to that in Latin America(all income levels)?
Your answer should be very brief. 0.85. What is the ratio of the Rating (1=low 6=high) in 2008 in Heavily indebted poor countries to that in Latin America(all income levels)?
Provide a short and direct response. 0.84. What is the ratio of the Rating (1=low 6=high) of 2005 in Heavily indebted poor countries to that in Latin America(developing only)?
Give a very brief answer. 0.85. What is the ratio of the Rating (1=low 6=high) of 2006 in Heavily indebted poor countries to that in Latin America(developing only)?
Provide a succinct answer. 0.85. What is the ratio of the Rating (1=low 6=high) in 2007 in Heavily indebted poor countries to that in Latin America(developing only)?
Your answer should be compact. 0.85. What is the ratio of the Rating (1=low 6=high) in 2008 in Heavily indebted poor countries to that in Latin America(developing only)?
Keep it short and to the point. 0.84. What is the ratio of the Rating (1=low 6=high) of 2008 in Latin America(all income levels) to that in Latin America(developing only)?
Provide a succinct answer. 1. What is the difference between the highest and the second highest Rating (1=low 6=high) of 2005?
Your answer should be compact. 0. What is the difference between the highest and the second highest Rating (1=low 6=high) in 2007?
Your response must be concise. 0. What is the difference between the highest and the lowest Rating (1=low 6=high) of 2005?
Your answer should be very brief. 0.86. What is the difference between the highest and the lowest Rating (1=low 6=high) of 2006?
Give a very brief answer. 0.92. What is the difference between the highest and the lowest Rating (1=low 6=high) in 2007?
Offer a very short reply. 0.93. What is the difference between the highest and the lowest Rating (1=low 6=high) of 2008?
Ensure brevity in your answer.  0.96. 